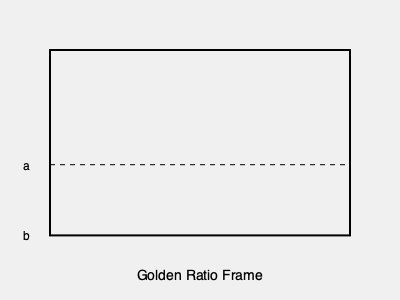In cinematography, the golden ratio is often used for composing shots. If a film frame is divided according to the golden ratio, and the larger section (a) measures 185.4 units, what is the length of the smaller section (b)? To solve this problem, we'll use the properties of the golden ratio and follow these steps:

1. Recall that the golden ratio is approximately 1.618, often denoted by the Greek letter φ (phi).

2. In a golden ratio division, the ratio of the whole to the larger part is equal to the ratio of the larger part to the smaller part. Mathematically:

   $$(a + b) : a = a : b$$

3. This can be simplified to:

   $$\frac{a + b}{a} = \frac{a}{b} = φ ≈ 1.618$$

4. We know that $a = 185.4$ units. Let's use this to find $b$:

   $$\frac{a}{b} = 1.618$$
   
   $$\frac{185.4}{b} = 1.618$$

5. Solve for $b$:

   $$b = \frac{185.4}{1.618} ≈ 114.6$$

6. Round to one decimal place:

   $$b ≈ 114.6 \text{ units}$$

Therefore, the length of the smaller section (b) is approximately 114.6 units.
Answer: 114.6 units 